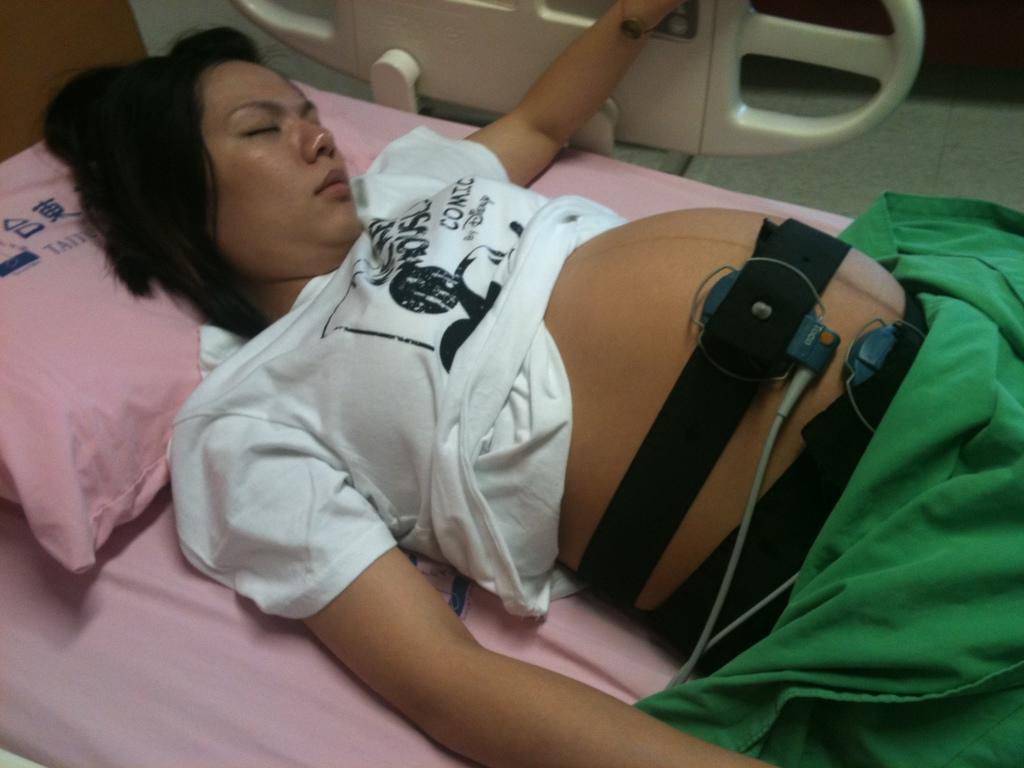In one or two sentences, can you explain what this image depicts? This is an inside view picture of a hospital. In this picture we can see a pregnant woman wearing a white t-shirt and she is sleeping on a bed. We can see a medical equipment around her belly. We can see a pillow and a green blanket. 